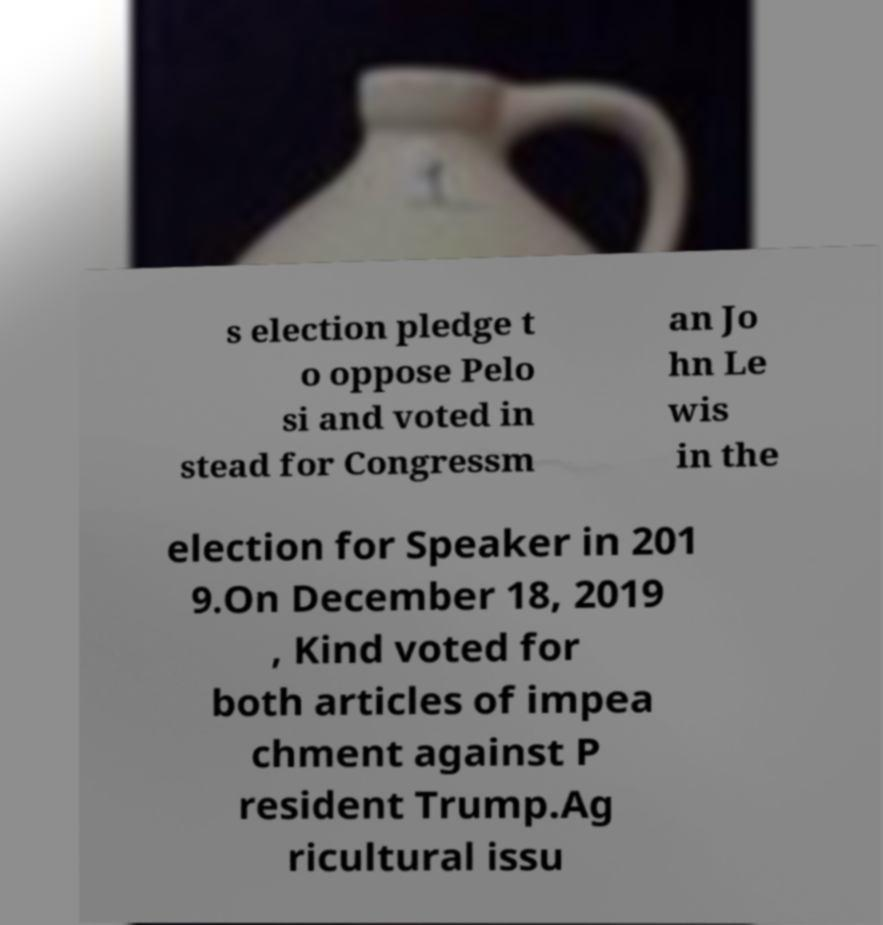For documentation purposes, I need the text within this image transcribed. Could you provide that? s election pledge t o oppose Pelo si and voted in stead for Congressm an Jo hn Le wis in the election for Speaker in 201 9.On December 18, 2019 , Kind voted for both articles of impea chment against P resident Trump.Ag ricultural issu 